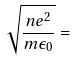Convert formula to latex. <formula><loc_0><loc_0><loc_500><loc_500>\sqrt { \frac { n e ^ { 2 } } { m \epsilon _ { 0 } } } =</formula> 